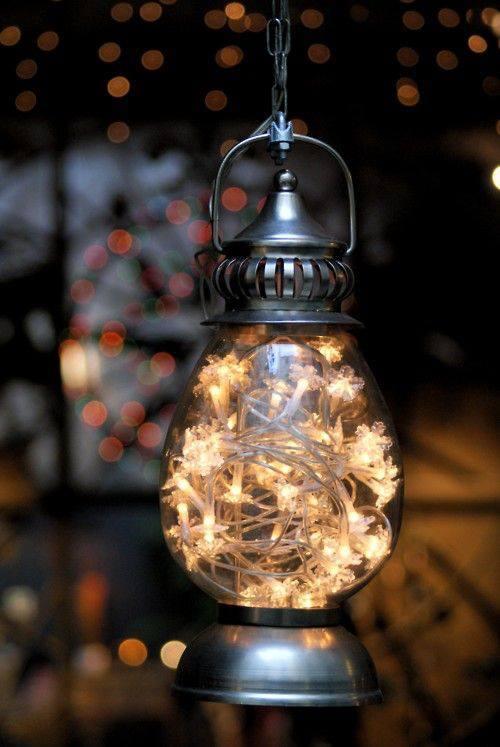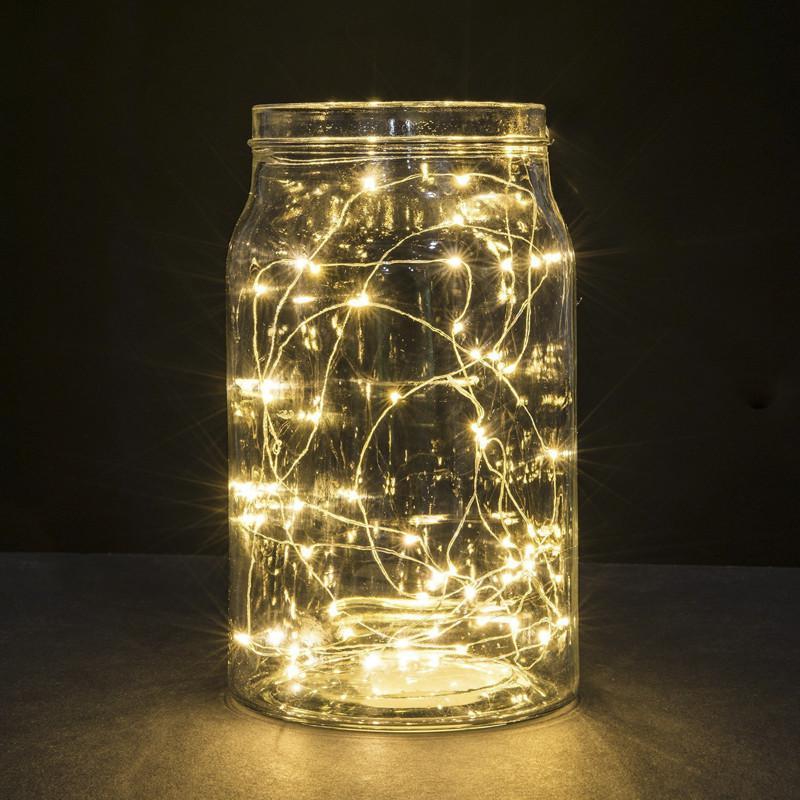The first image is the image on the left, the second image is the image on the right. For the images shown, is this caption "There are pine cones in at least one clear glass vase with stringed lights inside with them." true? Answer yes or no. No. The first image is the image on the left, the second image is the image on the right. Evaluate the accuracy of this statement regarding the images: "At least 1 glass container is decorated with pine cones and lights.". Is it true? Answer yes or no. No. 